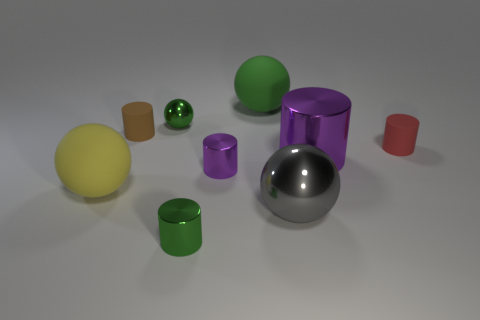Subtract all small brown cylinders. How many cylinders are left? 4 Subtract all gray cubes. How many purple cylinders are left? 2 Subtract all purple cylinders. How many cylinders are left? 3 Add 1 large metal blocks. How many objects exist? 10 Subtract 2 balls. How many balls are left? 2 Subtract all cylinders. How many objects are left? 4 Subtract all red cylinders. Subtract all cyan balls. How many cylinders are left? 4 Add 6 large gray things. How many large gray things are left? 7 Add 7 large green metallic cylinders. How many large green metallic cylinders exist? 7 Subtract 0 gray cylinders. How many objects are left? 9 